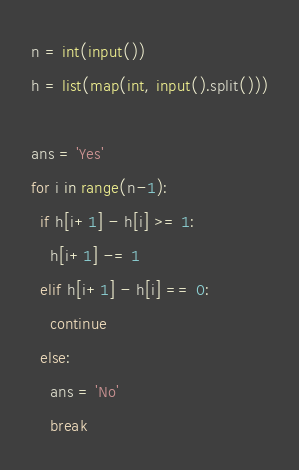Convert code to text. <code><loc_0><loc_0><loc_500><loc_500><_Python_>n = int(input())
h = list(map(int, input().split()))

ans = 'Yes'
for i in range(n-1):
  if h[i+1] - h[i] >= 1:
    h[i+1] -= 1
  elif h[i+1] - h[i] == 0:
    continue
  else:
    ans = 'No'
    break</code> 